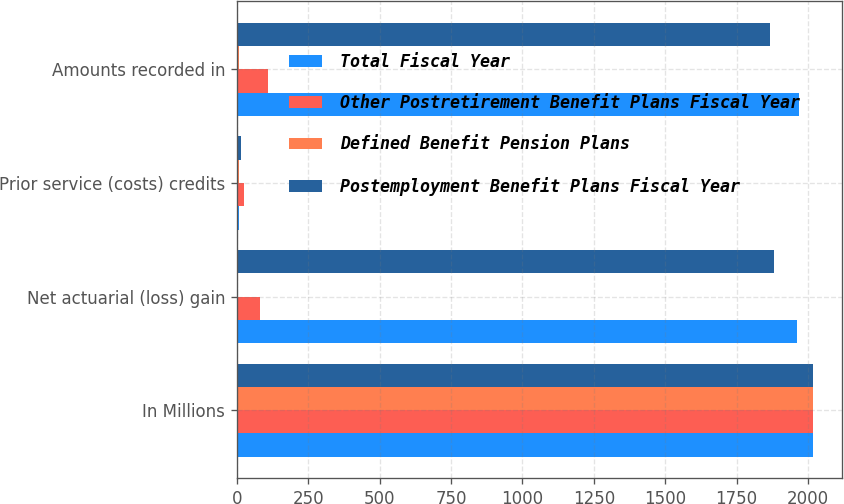Convert chart. <chart><loc_0><loc_0><loc_500><loc_500><stacked_bar_chart><ecel><fcel>In Millions<fcel>Net actuarial (loss) gain<fcel>Prior service (costs) credits<fcel>Amounts recorded in<nl><fcel>Total Fiscal Year<fcel>2019<fcel>1961.6<fcel>5.9<fcel>1967.5<nl><fcel>Other Postretirement Benefit Plans Fiscal Year<fcel>2019<fcel>81<fcel>26.3<fcel>107.3<nl><fcel>Defined Benefit Pension Plans<fcel>2019<fcel>0.1<fcel>6<fcel>5.9<nl><fcel>Postemployment Benefit Plans Fiscal Year<fcel>2019<fcel>1880.5<fcel>14.4<fcel>1866.1<nl></chart> 